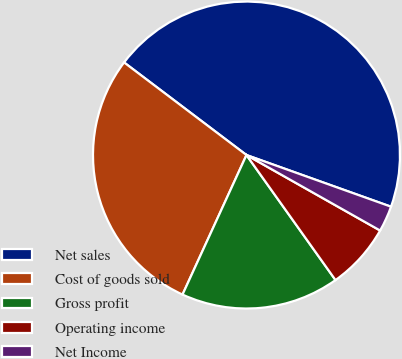Convert chart to OTSL. <chart><loc_0><loc_0><loc_500><loc_500><pie_chart><fcel>Net sales<fcel>Cost of goods sold<fcel>Gross profit<fcel>Operating income<fcel>Net Income<nl><fcel>45.16%<fcel>28.47%<fcel>16.69%<fcel>6.97%<fcel>2.72%<nl></chart> 